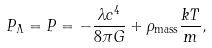Convert formula to latex. <formula><loc_0><loc_0><loc_500><loc_500>P _ { \Lambda } = P = - \frac { \lambda c ^ { 4 } } { 8 \pi G } + \rho _ { \text {mass} } \frac { k T } { m } ,</formula> 